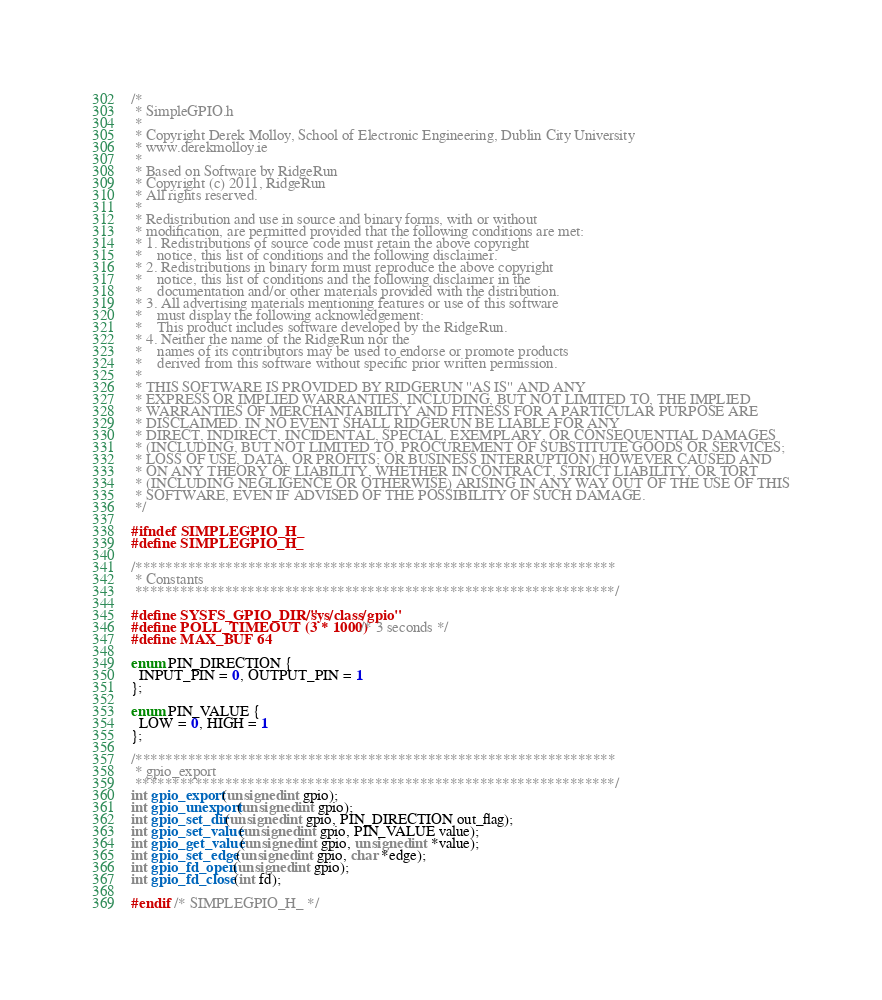<code> <loc_0><loc_0><loc_500><loc_500><_C_>/*
 * SimpleGPIO.h
 *
 * Copyright Derek Molloy, School of Electronic Engineering, Dublin City University
 * www.derekmolloy.ie
 *
 * Based on Software by RidgeRun
 * Copyright (c) 2011, RidgeRun
 * All rights reserved.
 *
 * Redistribution and use in source and binary forms, with or without
 * modification, are permitted provided that the following conditions are met:
 * 1. Redistributions of source code must retain the above copyright
 *    notice, this list of conditions and the following disclaimer.
 * 2. Redistributions in binary form must reproduce the above copyright
 *    notice, this list of conditions and the following disclaimer in the
 *    documentation and/or other materials provided with the distribution.
 * 3. All advertising materials mentioning features or use of this software
 *    must display the following acknowledgement:
 *    This product includes software developed by the RidgeRun.
 * 4. Neither the name of the RidgeRun nor the
 *    names of its contributors may be used to endorse or promote products
 *    derived from this software without specific prior written permission.
 *
 * THIS SOFTWARE IS PROVIDED BY RIDGERUN ''AS IS'' AND ANY
 * EXPRESS OR IMPLIED WARRANTIES, INCLUDING, BUT NOT LIMITED TO, THE IMPLIED
 * WARRANTIES OF MERCHANTABILITY AND FITNESS FOR A PARTICULAR PURPOSE ARE
 * DISCLAIMED. IN NO EVENT SHALL RIDGERUN BE LIABLE FOR ANY
 * DIRECT, INDIRECT, INCIDENTAL, SPECIAL, EXEMPLARY, OR CONSEQUENTIAL DAMAGES
 * (INCLUDING, BUT NOT LIMITED TO, PROCUREMENT OF SUBSTITUTE GOODS OR SERVICES;
 * LOSS OF USE, DATA, OR PROFITS; OR BUSINESS INTERRUPTION) HOWEVER CAUSED AND
 * ON ANY THEORY OF LIABILITY, WHETHER IN CONTRACT, STRICT LIABILITY, OR TORT
 * (INCLUDING NEGLIGENCE OR OTHERWISE) ARISING IN ANY WAY OUT OF THE USE OF THIS
 * SOFTWARE, EVEN IF ADVISED OF THE POSSIBILITY OF SUCH DAMAGE.
 */

#ifndef SIMPLEGPIO_H_
#define SIMPLEGPIO_H_

/****************************************************************
 * Constants
 ****************************************************************/

#define SYSFS_GPIO_DIR "/sys/class/gpio"
#define POLL_TIMEOUT (3 * 1000) /* 3 seconds */
#define MAX_BUF 64

enum PIN_DIRECTION {
  INPUT_PIN = 0, OUTPUT_PIN = 1
};

enum PIN_VALUE {
  LOW = 0, HIGH = 1
};

/****************************************************************
 * gpio_export
 ****************************************************************/
int gpio_export(unsigned int gpio);
int gpio_unexport(unsigned int gpio);
int gpio_set_dir(unsigned int gpio, PIN_DIRECTION out_flag);
int gpio_set_value(unsigned int gpio, PIN_VALUE value);
int gpio_get_value(unsigned int gpio, unsigned int *value);
int gpio_set_edge(unsigned int gpio, char *edge);
int gpio_fd_open(unsigned int gpio);
int gpio_fd_close(int fd);

#endif /* SIMPLEGPIO_H_ */
</code> 